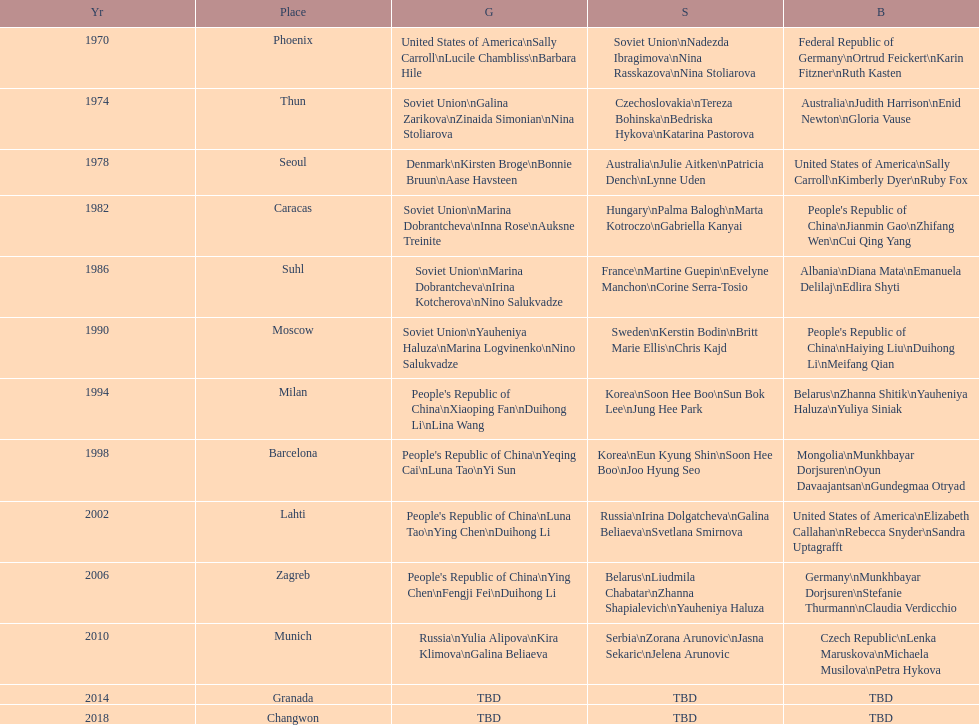What is the number of total bronze medals that germany has won? 1. 